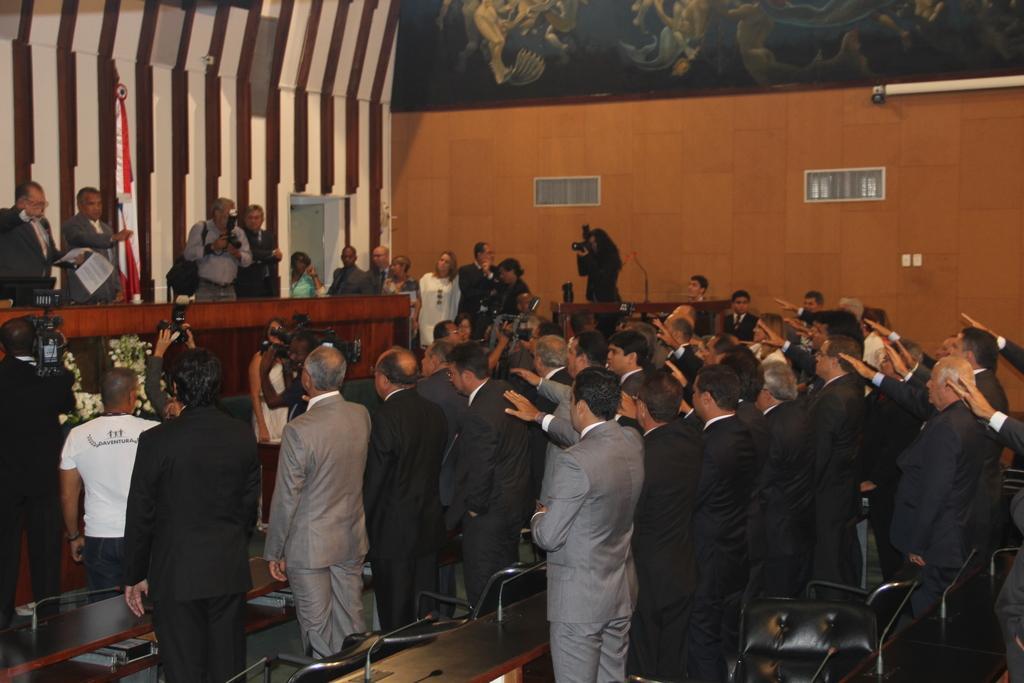Describe this image in one or two sentences. In this image there are group of people standing , there are chairs, tables, mikes, group of people holding cameras, flower bouquets , frame attached to the wall, badges. 